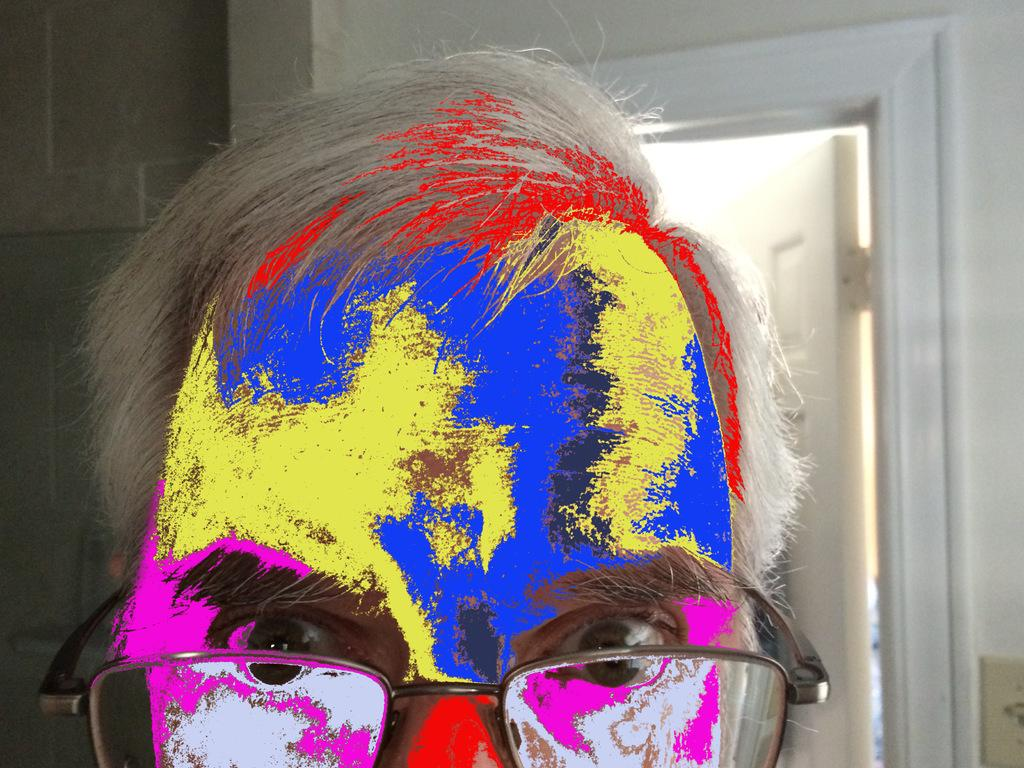Who or what is present in the image? There is a person in the image. What is behind the person in the image? There is a wall behind the person. What feature can be seen on the wall? There is a door on the wall. What type of honey is being served on the boat in the image? There is no honey or boat present in the image. 